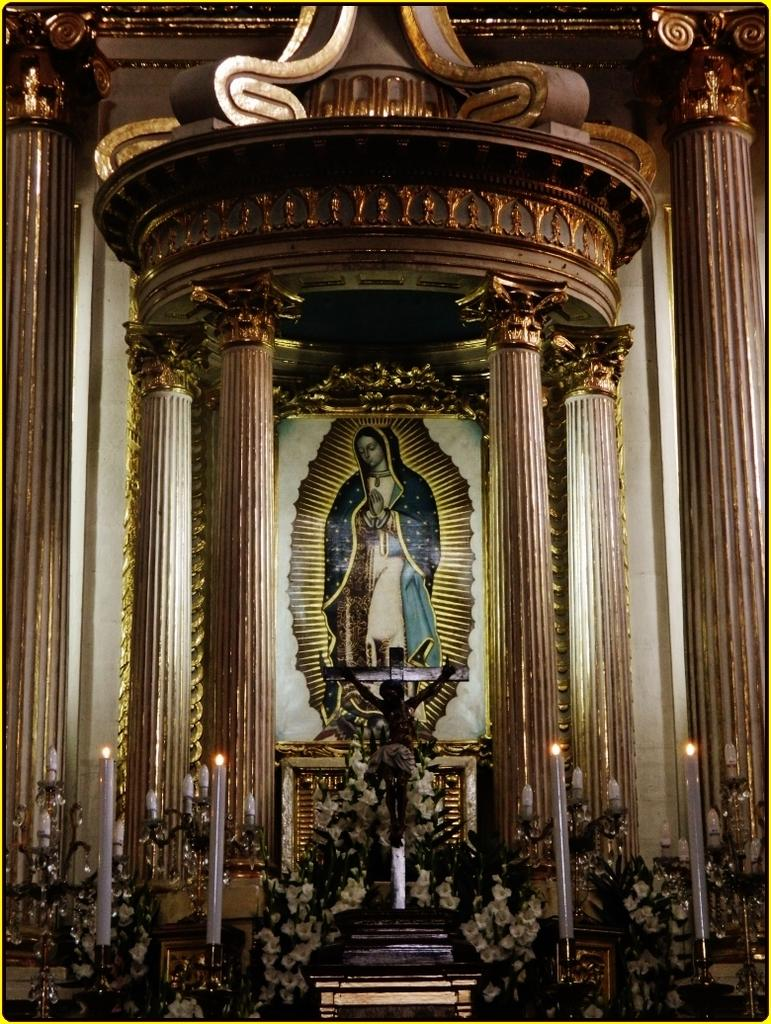What religious symbol is present in the image? There is a cross in the image. What type of decorative elements can be seen in the image? There are flowers and candles in the image. What is the main focus of the image? There is an art piece in the middle of the image. What architectural features are present on both sides of the image? There are pillars on the left side and the right side of the image. What type of star can be seen in the design of the art piece in the image? There is no star present in the design of the art piece in the image. What scene is depicted in the art piece in the image? The art piece in the image does not depict a specific scene; it is an abstract piece. 